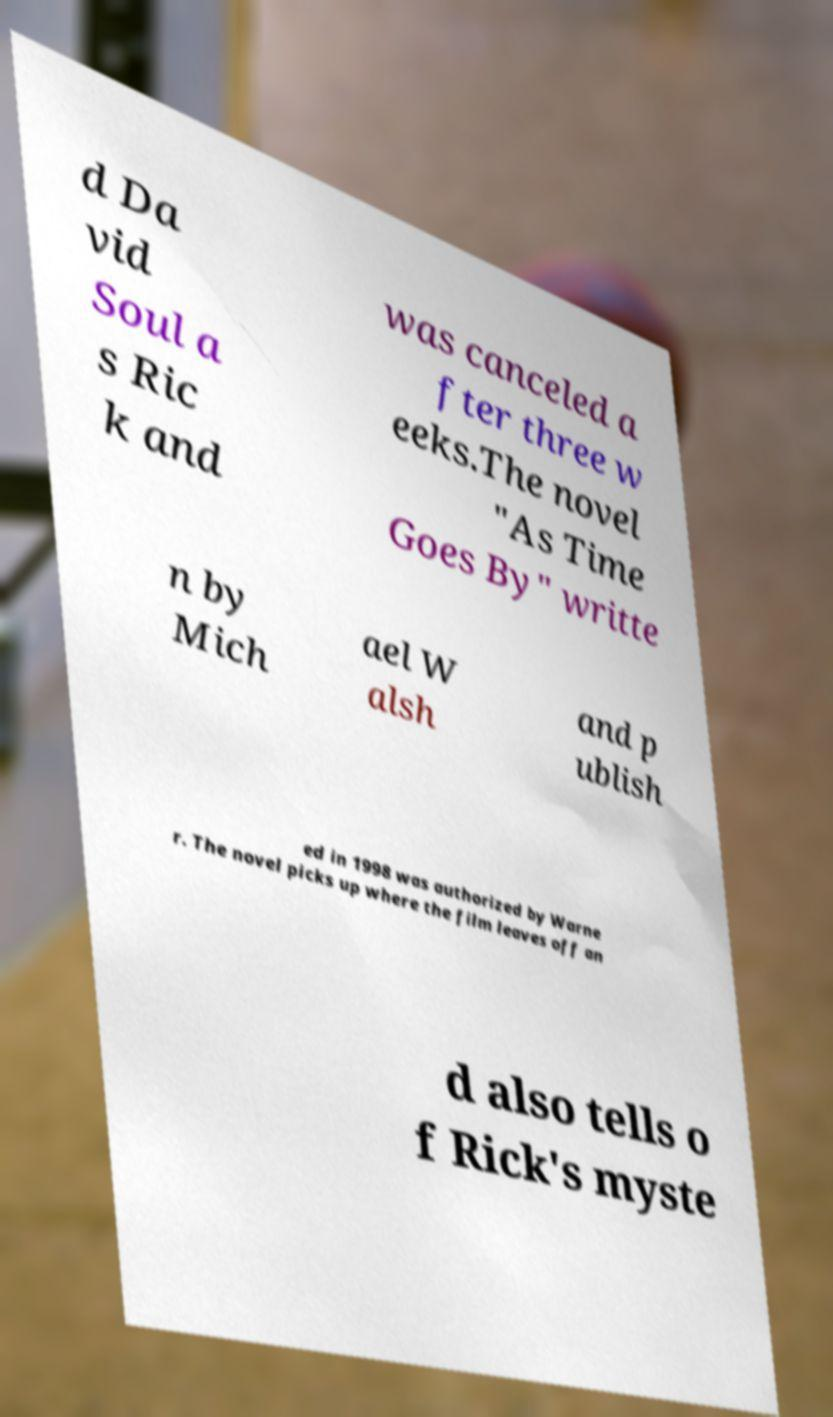What messages or text are displayed in this image? I need them in a readable, typed format. d Da vid Soul a s Ric k and was canceled a fter three w eeks.The novel "As Time Goes By" writte n by Mich ael W alsh and p ublish ed in 1998 was authorized by Warne r. The novel picks up where the film leaves off an d also tells o f Rick's myste 